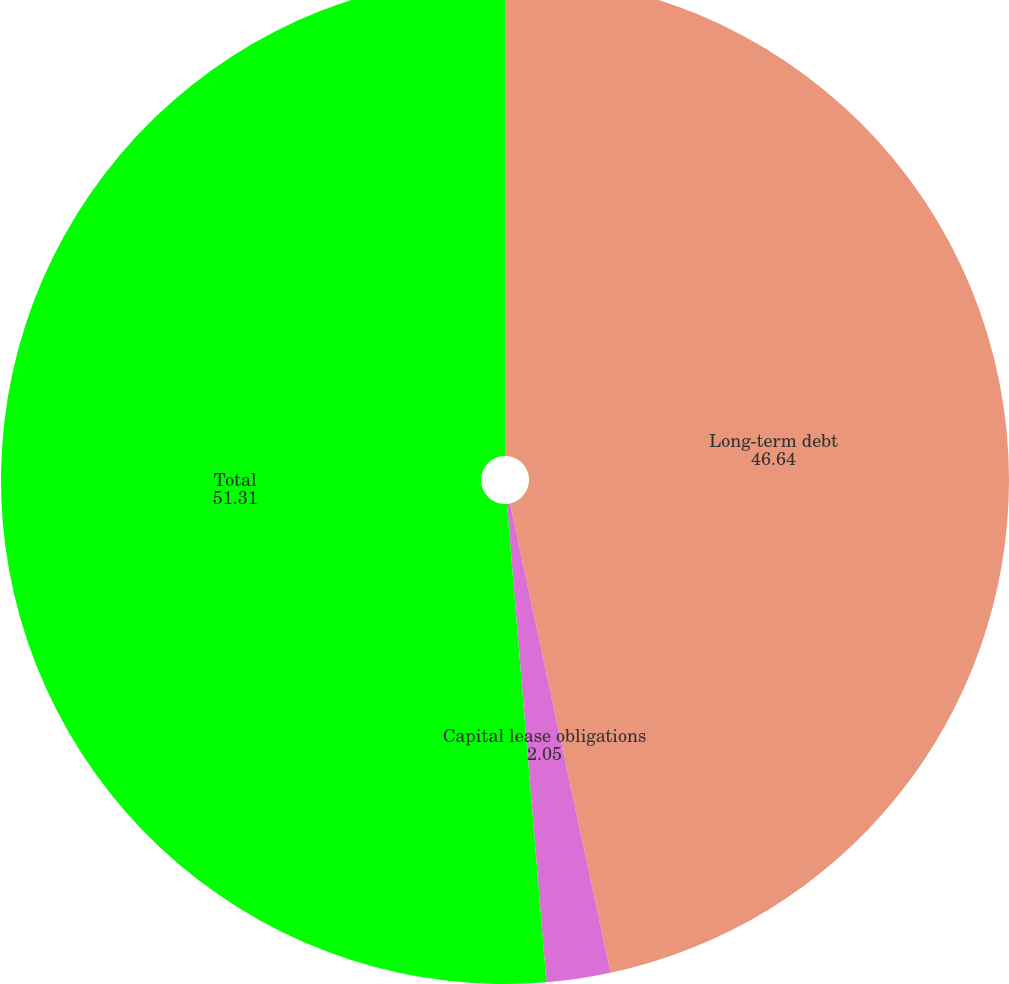Convert chart to OTSL. <chart><loc_0><loc_0><loc_500><loc_500><pie_chart><fcel>Long-term debt<fcel>Capital lease obligations<fcel>Total<nl><fcel>46.64%<fcel>2.05%<fcel>51.31%<nl></chart> 